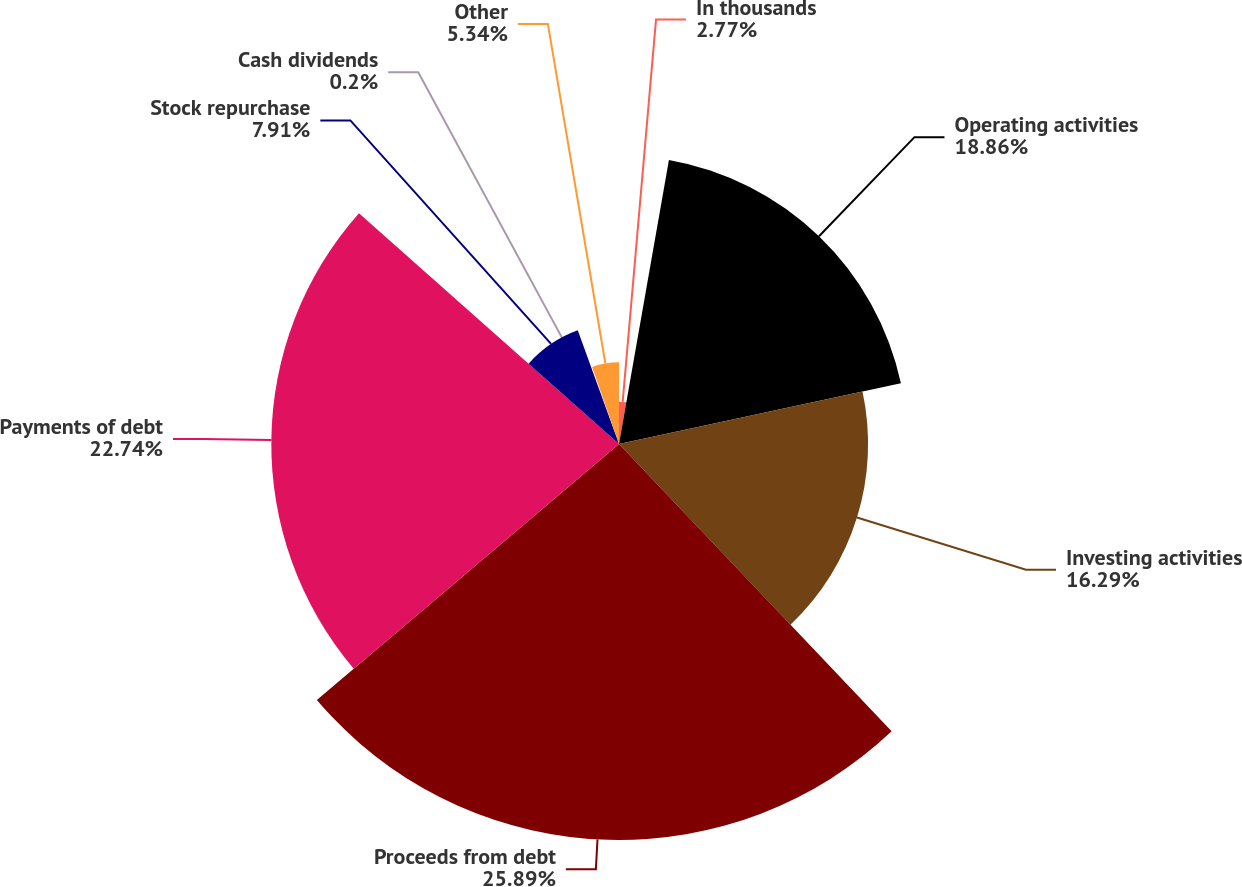<chart> <loc_0><loc_0><loc_500><loc_500><pie_chart><fcel>In thousands<fcel>Operating activities<fcel>Investing activities<fcel>Proceeds from debt<fcel>Payments of debt<fcel>Stock repurchase<fcel>Cash dividends<fcel>Other<nl><fcel>2.77%<fcel>18.86%<fcel>16.29%<fcel>25.9%<fcel>22.74%<fcel>7.91%<fcel>0.2%<fcel>5.34%<nl></chart> 